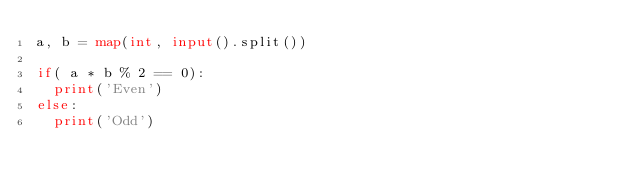<code> <loc_0><loc_0><loc_500><loc_500><_Python_>a, b = map(int, input().split())

if( a * b % 2 == 0):
  print('Even')
else:
  print('Odd')</code> 